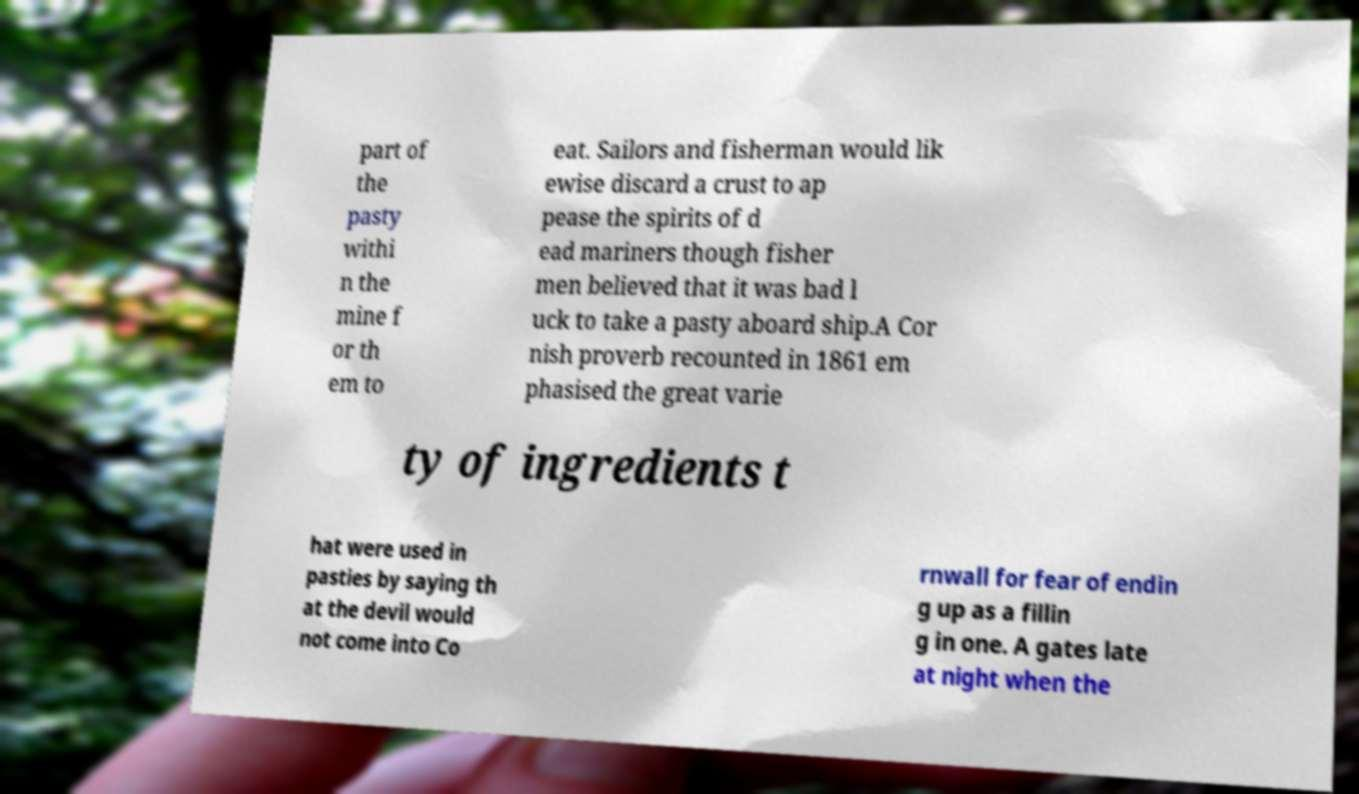Please read and relay the text visible in this image. What does it say? part of the pasty withi n the mine f or th em to eat. Sailors and fisherman would lik ewise discard a crust to ap pease the spirits of d ead mariners though fisher men believed that it was bad l uck to take a pasty aboard ship.A Cor nish proverb recounted in 1861 em phasised the great varie ty of ingredients t hat were used in pasties by saying th at the devil would not come into Co rnwall for fear of endin g up as a fillin g in one. A gates late at night when the 